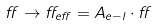<formula> <loc_0><loc_0><loc_500><loc_500>\alpha \rightarrow \alpha _ { e f f } = A _ { e - l } \cdot \alpha</formula> 